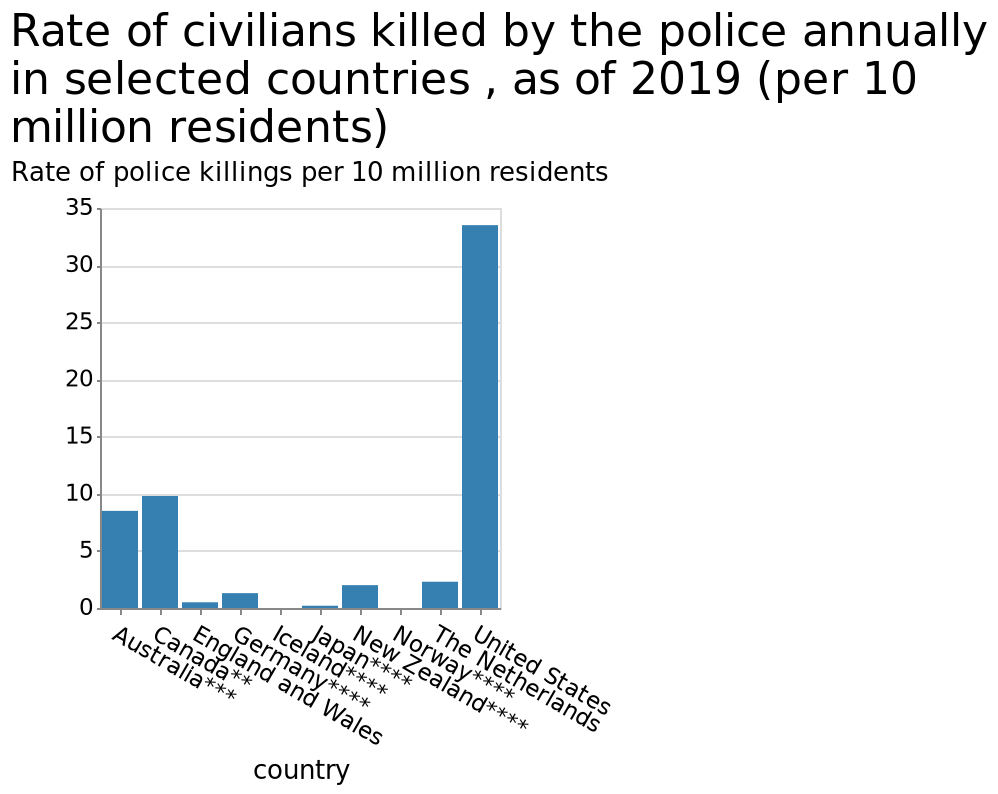<image>
please summary the statistics and relations of the chart America has 7 times more police related fatalities than Australia towering over all over country's on the list. What is the unit of measurement for the rate of police killings in the bar diagram? The unit of measurement for the rate of police killings in the bar diagram is per 10 million residents. How does America's police-related fatalities compare to other countries on the list?  America's police-related fatalities tower over all other countries on the list. 